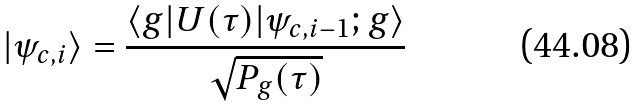Convert formula to latex. <formula><loc_0><loc_0><loc_500><loc_500>| \psi _ { c , i } \rangle = \frac { \langle g | U ( \tau ) | \psi _ { c , i - 1 } ; g \rangle } { \sqrt { P _ { g } ( \tau ) } }</formula> 